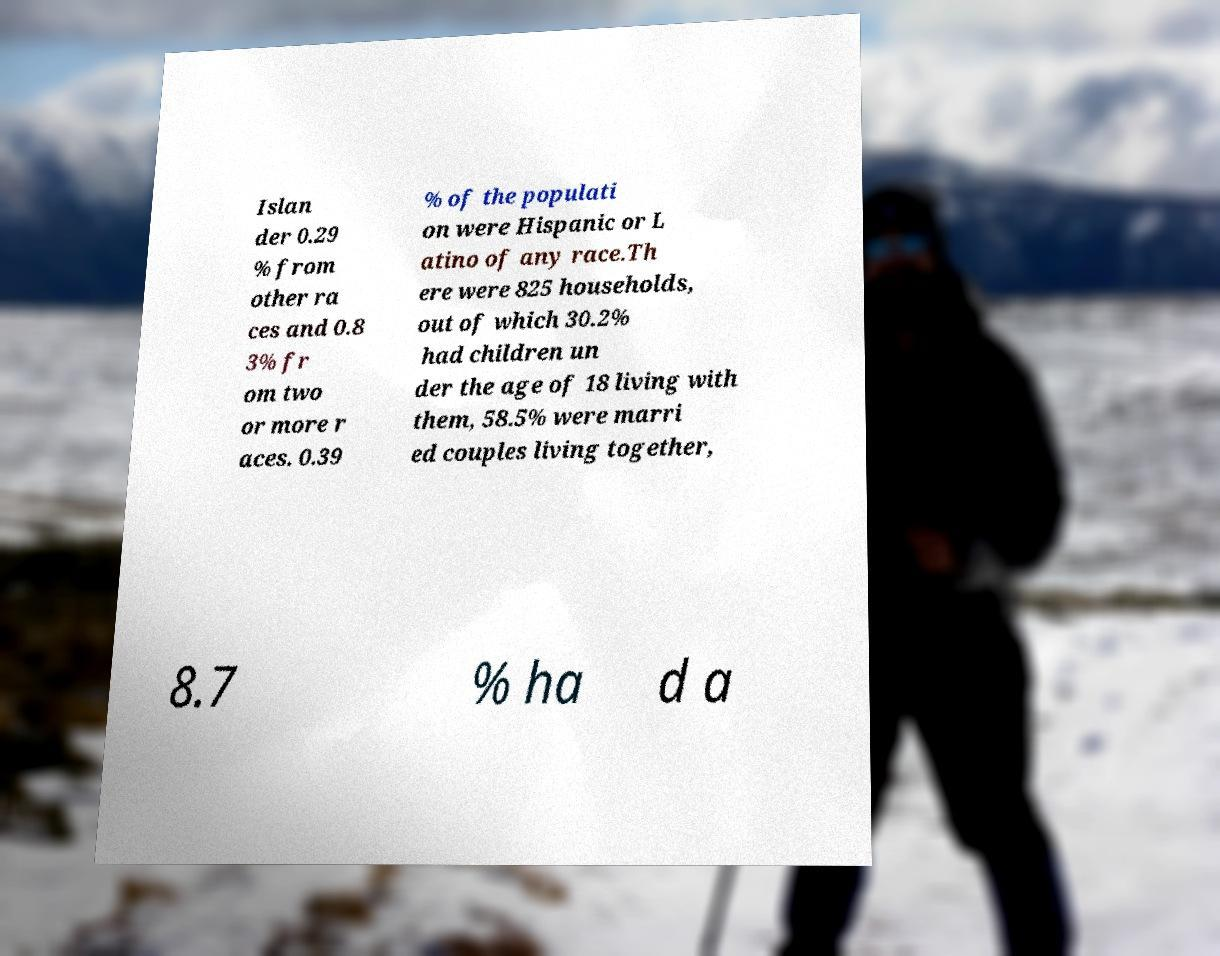Please identify and transcribe the text found in this image. Islan der 0.29 % from other ra ces and 0.8 3% fr om two or more r aces. 0.39 % of the populati on were Hispanic or L atino of any race.Th ere were 825 households, out of which 30.2% had children un der the age of 18 living with them, 58.5% were marri ed couples living together, 8.7 % ha d a 